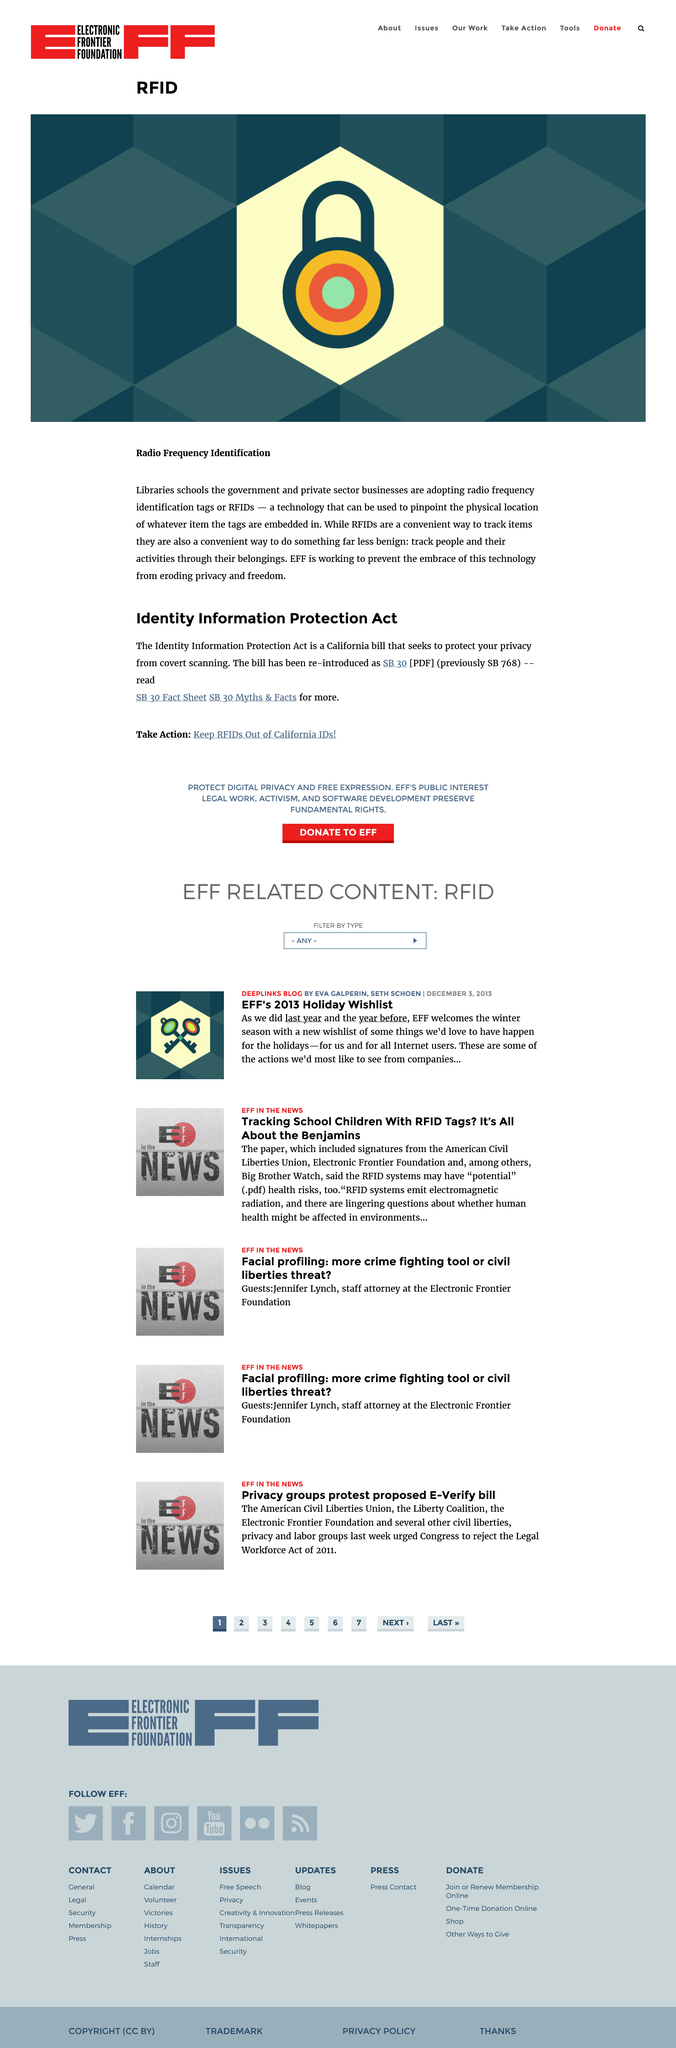Indicate a few pertinent items in this graphic. Radio Frequency Identification Tags, commonly referred to as RFID, is a technology that uses radio waves to identify and track objects, such as products or individuals, wirelessly. The Identity Information Protection Act aims to safeguard individuals' privacy by prohibiting covert scanning, which refers to the unauthorized collection of personal information through technology or other means. RFID (Radio Frequency Identification) tags are used to pinpoint the physical location of items that are embedded with the tags by using radio waves to transmit information about the items' unique identification numbers. 